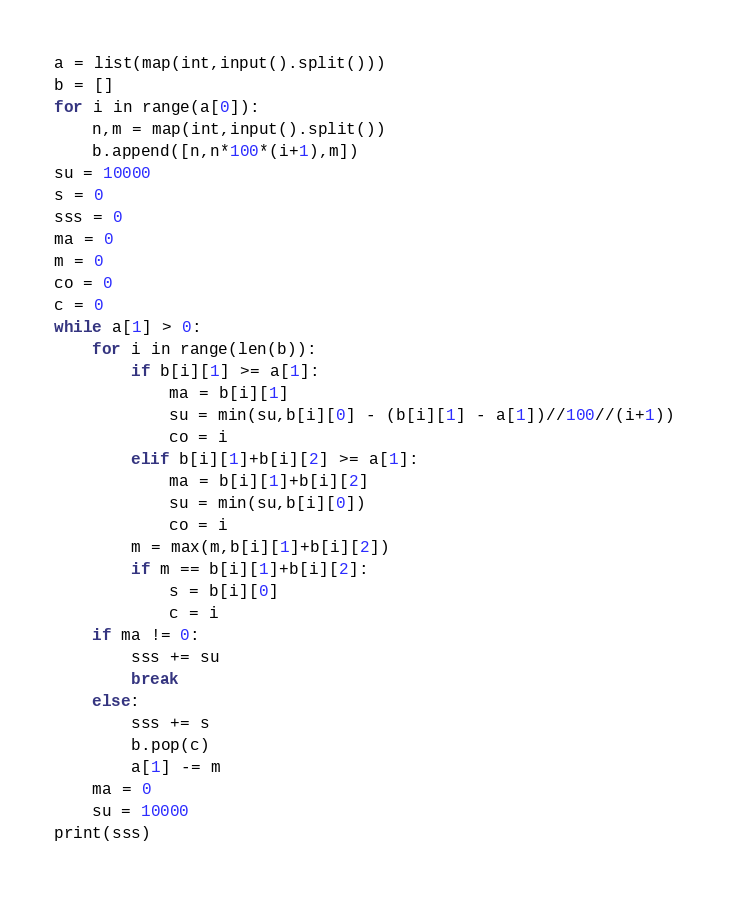<code> <loc_0><loc_0><loc_500><loc_500><_Python_>a = list(map(int,input().split()))
b = []
for i in range(a[0]):
	n,m = map(int,input().split())
	b.append([n,n*100*(i+1),m])
su = 10000
s = 0
sss = 0
ma = 0
m = 0
co = 0
c = 0
while a[1] > 0:
	for i in range(len(b)):
		if b[i][1] >= a[1]:
			ma = b[i][1]
			su = min(su,b[i][0] - (b[i][1] - a[1])//100//(i+1))
			co = i
		elif b[i][1]+b[i][2] >= a[1]:
			ma = b[i][1]+b[i][2]
			su = min(su,b[i][0])
			co = i
		m = max(m,b[i][1]+b[i][2])
		if m == b[i][1]+b[i][2]:
			s = b[i][0]
			c = i
	if ma != 0:
		sss += su
		break
	else:
		sss += s
		b.pop(c)
		a[1] -= m
	ma = 0
	su = 10000
print(sss)</code> 